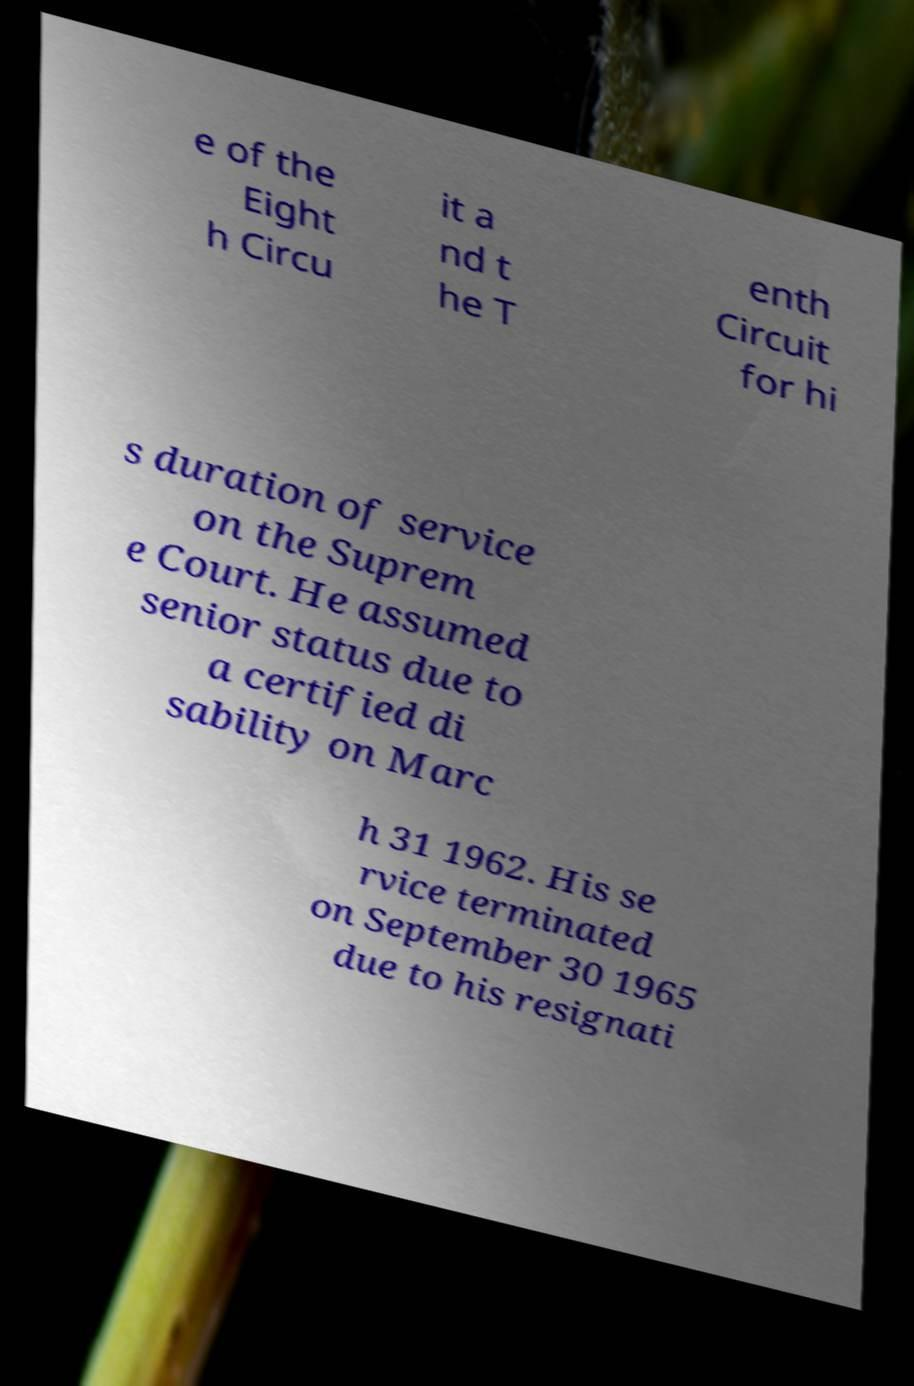Can you accurately transcribe the text from the provided image for me? e of the Eight h Circu it a nd t he T enth Circuit for hi s duration of service on the Suprem e Court. He assumed senior status due to a certified di sability on Marc h 31 1962. His se rvice terminated on September 30 1965 due to his resignati 